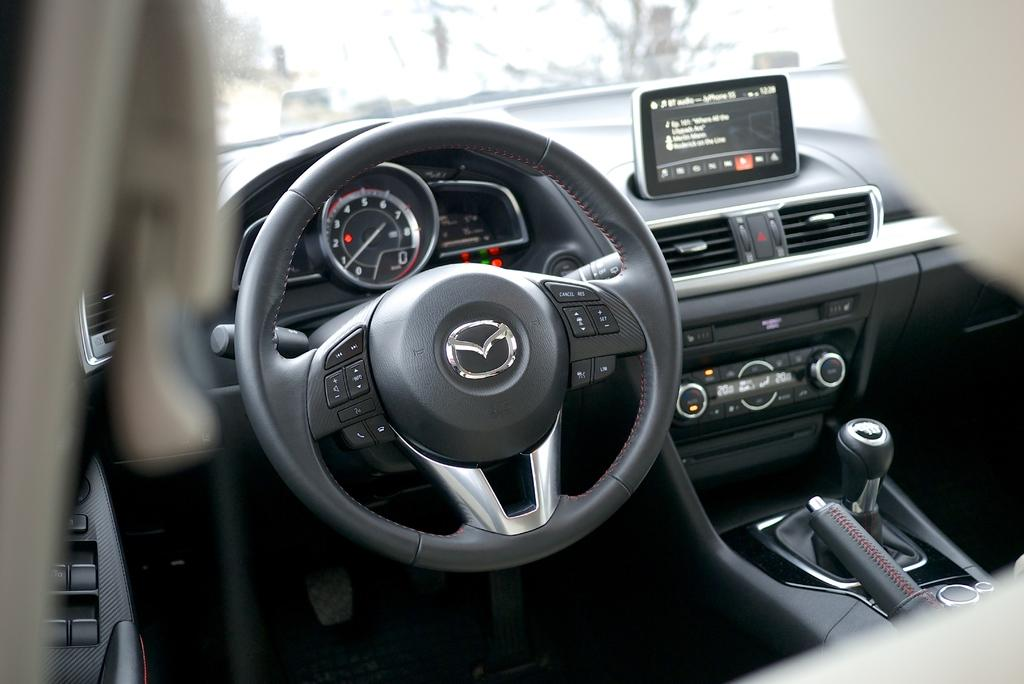What is the location from where the image was taken? The image is captured from inside a car. What is the main object visible in the image? The steering wheel is visible in the image. What other car parts can be seen in the image? The gear rod, speedometer, and other car parts are visible in the image. Is there a lamp visible in the image? No, there is no lamp present in the image. What is the temperature inside the car in the image? The provided facts do not mention the temperature inside the car, so it cannot be determined from the image. 